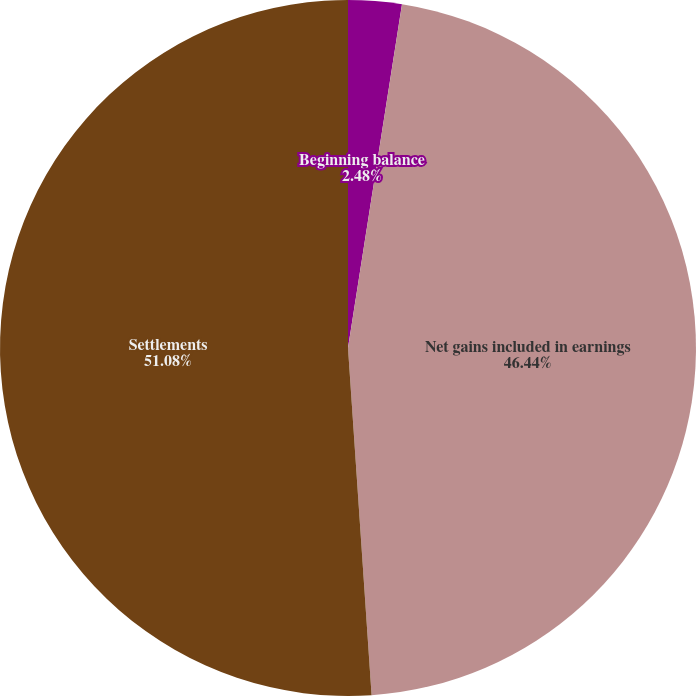Convert chart. <chart><loc_0><loc_0><loc_500><loc_500><pie_chart><fcel>Beginning balance<fcel>Net gains included in earnings<fcel>Settlements<nl><fcel>2.48%<fcel>46.44%<fcel>51.08%<nl></chart> 